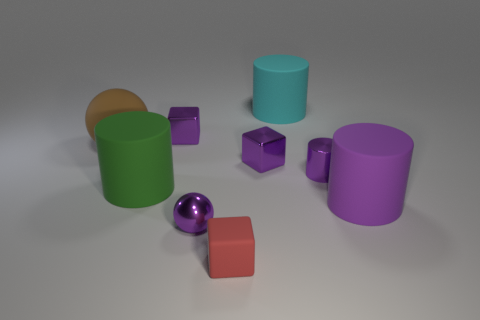Is the number of big cyan rubber objects that are to the right of the tiny cylinder less than the number of small cyan things?
Your answer should be very brief. No. There is a small thing that is right of the large rubber object behind the large ball that is behind the large purple thing; what shape is it?
Provide a short and direct response. Cylinder. Is the tiny shiny cylinder the same color as the matte block?
Make the answer very short. No. Are there more yellow rubber objects than brown objects?
Ensure brevity in your answer.  No. What number of other things are the same material as the small red object?
Offer a very short reply. 4. How many things are either tiny shiny cylinders or metallic objects behind the brown sphere?
Give a very brief answer. 2. Is the number of tiny purple cylinders less than the number of tiny yellow matte cubes?
Provide a short and direct response. No. There is a large rubber cylinder on the left side of the sphere that is right of the purple cube that is behind the big ball; what color is it?
Give a very brief answer. Green. Is the small cylinder made of the same material as the big purple cylinder?
Keep it short and to the point. No. There is a small red object; what number of metal things are left of it?
Offer a very short reply. 2. 